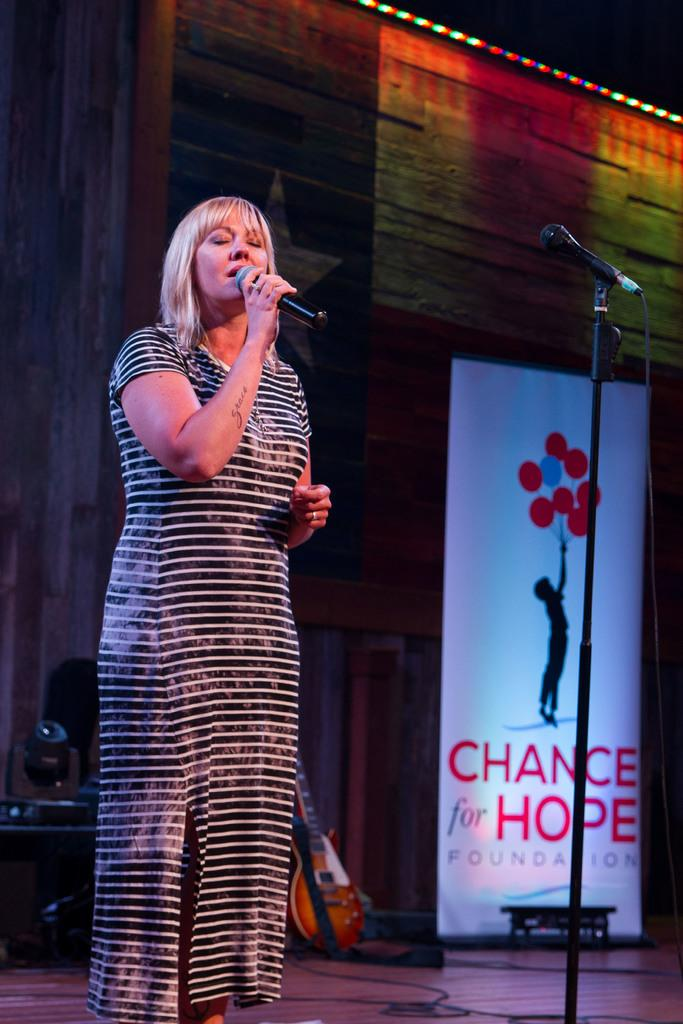What is the woman in the image doing? The woman is singing in front of a microphone. What can be seen beside a wall in the image? There is a banner beside a wall in the image. What objects are related to music in the image? Musical instruments and a microphone with a holder are present in the image. Can you tell me how many times the pan has been used in the image? There is no pan present in the image, so it cannot be determined how many times it has been used. 